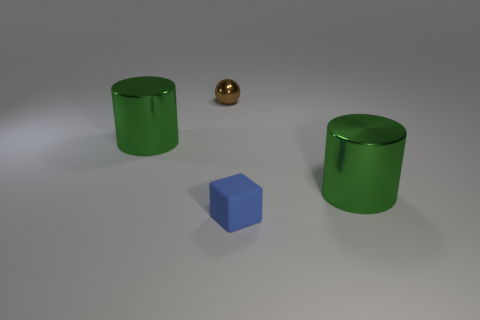Add 3 big green metallic things. How many objects exist? 7 Subtract 1 spheres. How many spheres are left? 0 Subtract all balls. How many objects are left? 3 Subtract all brown cylinders. Subtract all brown blocks. How many cylinders are left? 2 Subtract all brown balls. How many purple cubes are left? 0 Subtract all large blue cylinders. Subtract all green metal cylinders. How many objects are left? 2 Add 4 brown balls. How many brown balls are left? 5 Add 1 big brown cubes. How many big brown cubes exist? 1 Subtract 0 red balls. How many objects are left? 4 